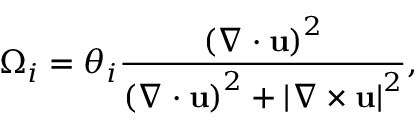Convert formula to latex. <formula><loc_0><loc_0><loc_500><loc_500>\Omega _ { i } = \theta _ { i } \frac { \left ( \nabla \cdot u \right ) ^ { 2 } } { \left ( \nabla \cdot u \right ) ^ { 2 } + \left | \nabla \times u \right | ^ { 2 } } ,</formula> 